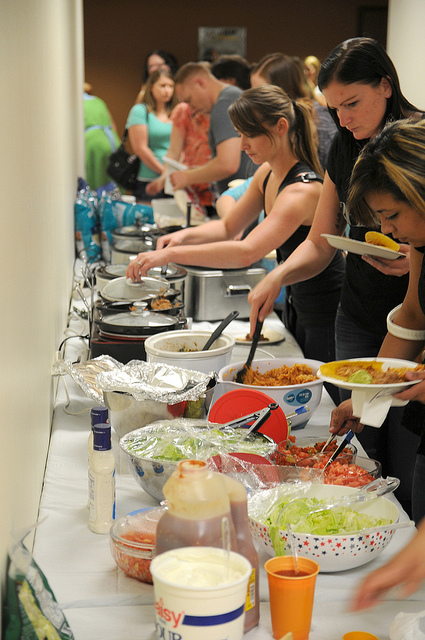How many bottles are visible? After carefully examining the visible items, it appears there is at least one bottle on the table, partially obscured by other objects, specifically situated near the bowl with a red lid. 